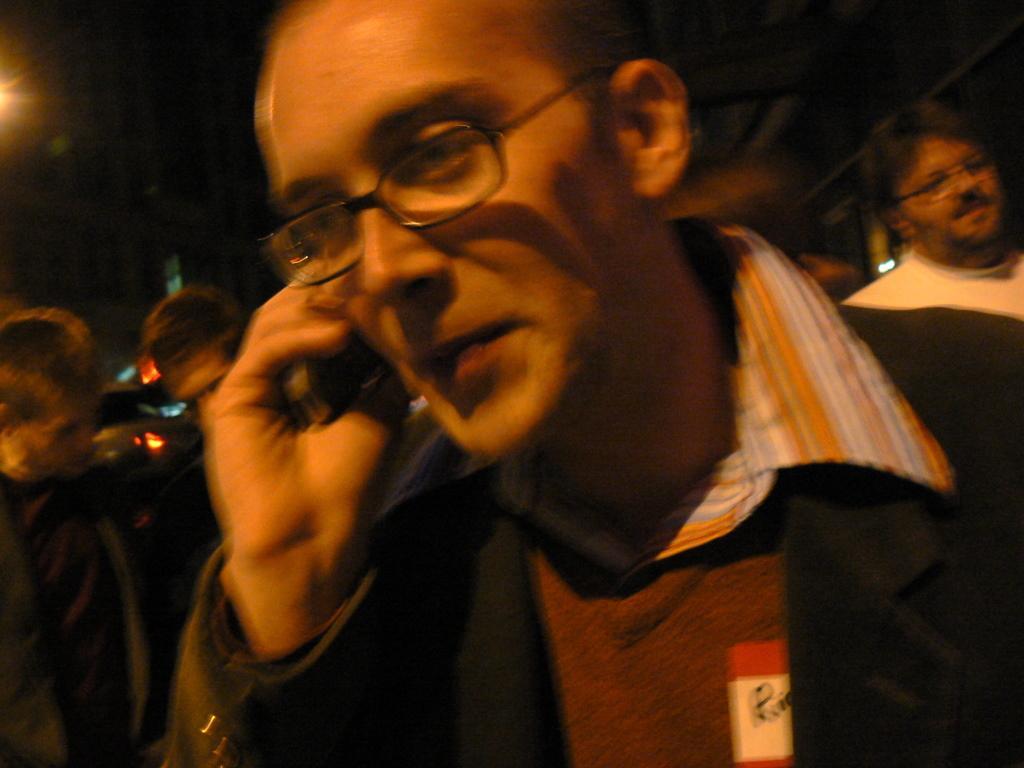Can you describe this image briefly? Background portion of the picture is dark and we can see the people, lights. This picture is mainly highlighted with a man wearing spectacles and he is holding a black object in his hand. 